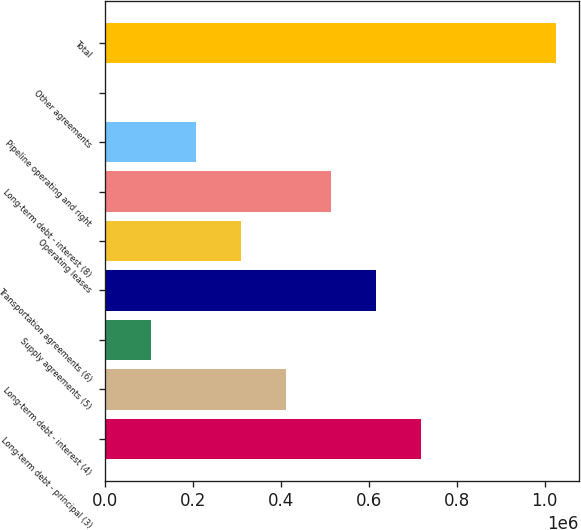Convert chart. <chart><loc_0><loc_0><loc_500><loc_500><bar_chart><fcel>Long-term debt - principal (3)<fcel>Long-term debt - interest (4)<fcel>Supply agreements (5)<fcel>Transportation agreements (6)<fcel>Operating leases<fcel>Long-term debt - interest (8)<fcel>Pipeline operating and right<fcel>Other agreements<fcel>Total<nl><fcel>718789<fcel>411905<fcel>105020<fcel>616494<fcel>309610<fcel>514200<fcel>207315<fcel>2725<fcel>1.02567e+06<nl></chart> 